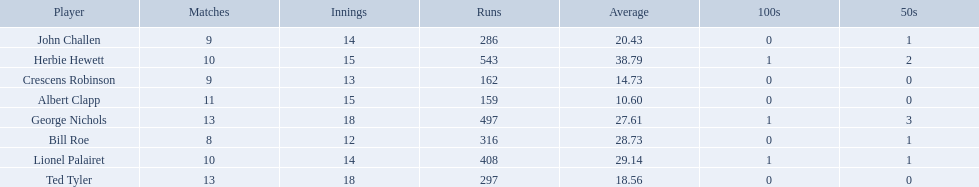Who are the players in somerset county cricket club in 1890? Herbie Hewett, Lionel Palairet, Bill Roe, George Nichols, John Challen, Ted Tyler, Crescens Robinson, Albert Clapp. Who is the only player to play less than 13 innings? Bill Roe. 